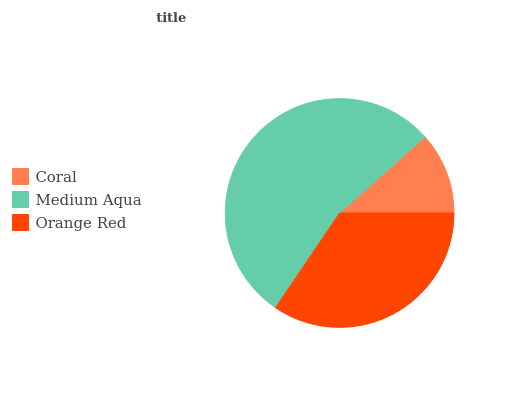Is Coral the minimum?
Answer yes or no. Yes. Is Medium Aqua the maximum?
Answer yes or no. Yes. Is Orange Red the minimum?
Answer yes or no. No. Is Orange Red the maximum?
Answer yes or no. No. Is Medium Aqua greater than Orange Red?
Answer yes or no. Yes. Is Orange Red less than Medium Aqua?
Answer yes or no. Yes. Is Orange Red greater than Medium Aqua?
Answer yes or no. No. Is Medium Aqua less than Orange Red?
Answer yes or no. No. Is Orange Red the high median?
Answer yes or no. Yes. Is Orange Red the low median?
Answer yes or no. Yes. Is Coral the high median?
Answer yes or no. No. Is Coral the low median?
Answer yes or no. No. 